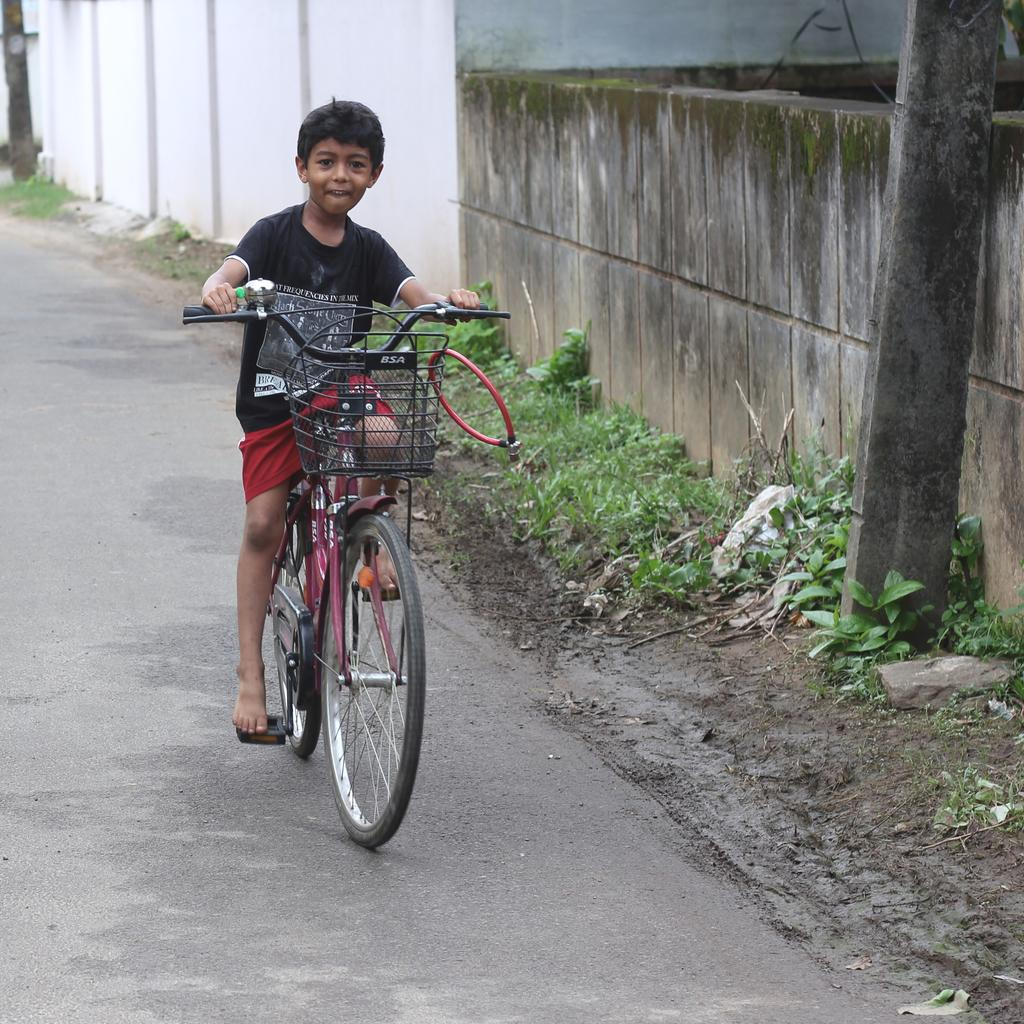Who is the main subject in the image? There is a boy in the image. Where is the boy located in the image? The boy is in the center of the image. What is the boy doing in the image? The boy is riding a bicycle. What is the setting of the image? The bicycle is on the road. What type of frame is the boy using to ride the bicycle in the image? There is no frame mentioned or visible in the image; the boy is simply riding a bicycle. How does the wind affect the boy's ride in the image? There is no mention of wind in the image, so its effect on the boy's ride cannot be determined. 